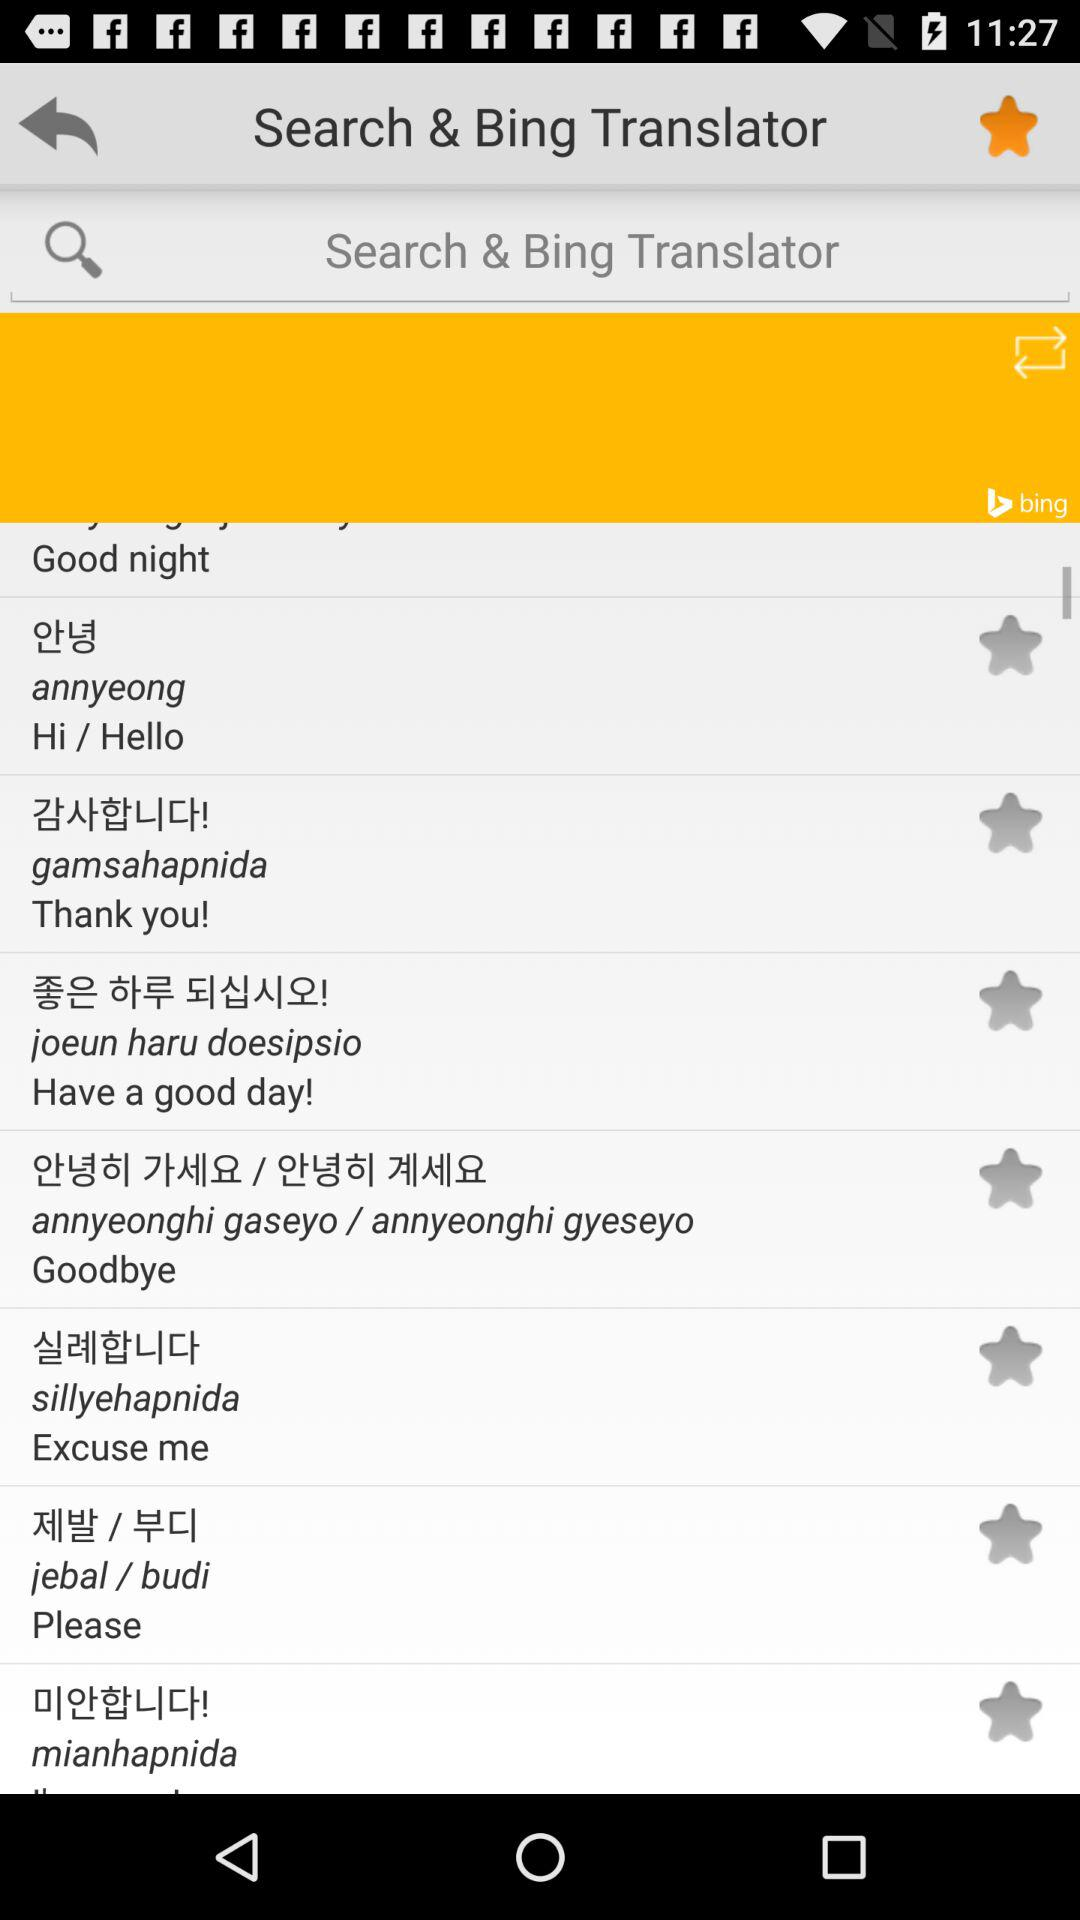How do I return to the previous menu?
When the provided information is insufficient, respond with <no answer>. <no answer> 